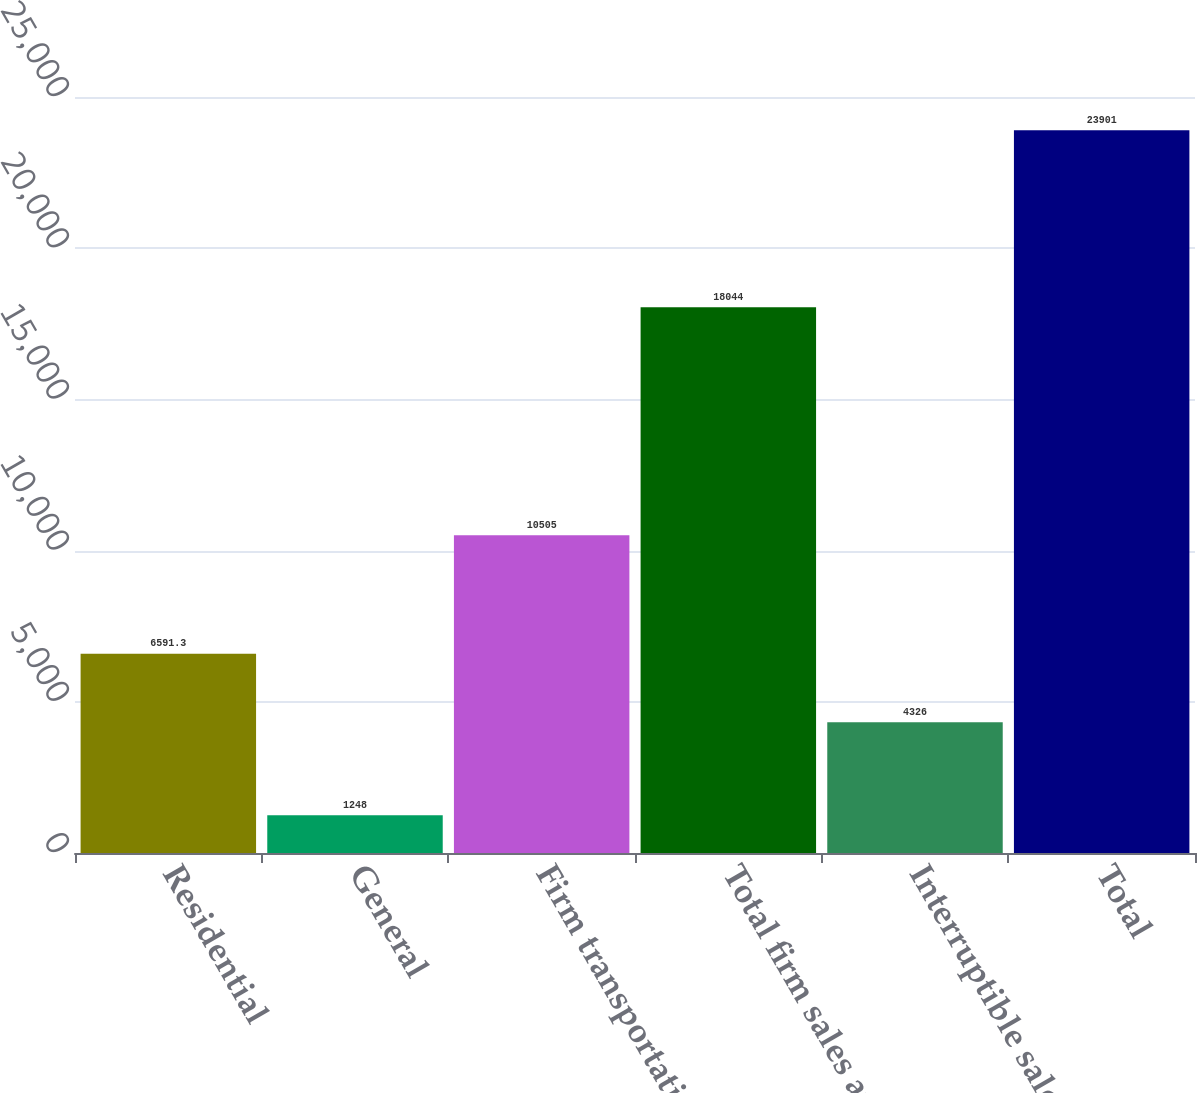Convert chart to OTSL. <chart><loc_0><loc_0><loc_500><loc_500><bar_chart><fcel>Residential<fcel>General<fcel>Firm transportation<fcel>Total firm sales and<fcel>Interruptible sales<fcel>Total<nl><fcel>6591.3<fcel>1248<fcel>10505<fcel>18044<fcel>4326<fcel>23901<nl></chart> 